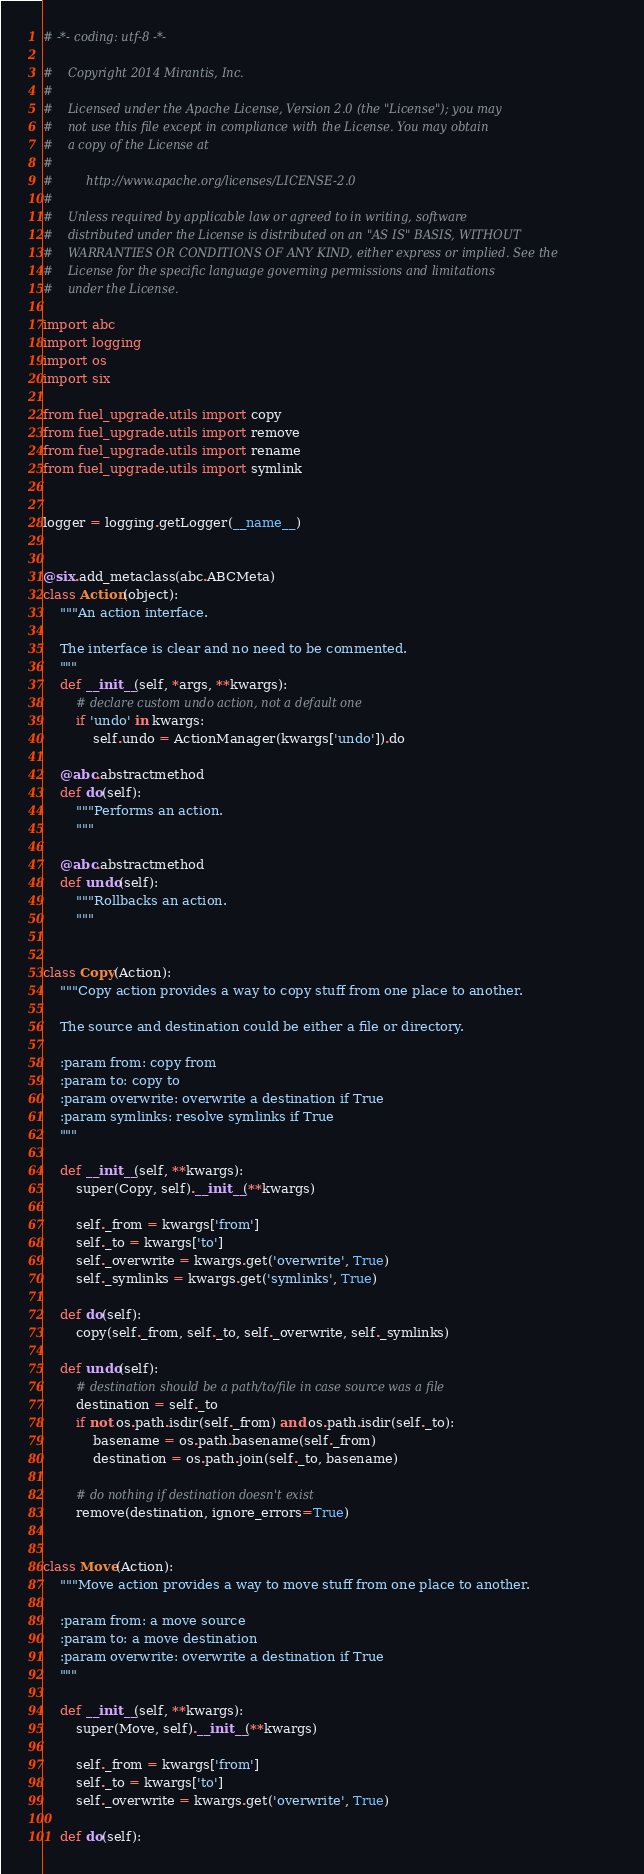<code> <loc_0><loc_0><loc_500><loc_500><_Python_># -*- coding: utf-8 -*-

#    Copyright 2014 Mirantis, Inc.
#
#    Licensed under the Apache License, Version 2.0 (the "License"); you may
#    not use this file except in compliance with the License. You may obtain
#    a copy of the License at
#
#         http://www.apache.org/licenses/LICENSE-2.0
#
#    Unless required by applicable law or agreed to in writing, software
#    distributed under the License is distributed on an "AS IS" BASIS, WITHOUT
#    WARRANTIES OR CONDITIONS OF ANY KIND, either express or implied. See the
#    License for the specific language governing permissions and limitations
#    under the License.

import abc
import logging
import os
import six

from fuel_upgrade.utils import copy
from fuel_upgrade.utils import remove
from fuel_upgrade.utils import rename
from fuel_upgrade.utils import symlink


logger = logging.getLogger(__name__)


@six.add_metaclass(abc.ABCMeta)
class Action(object):
    """An action interface.

    The interface is clear and no need to be commented.
    """
    def __init__(self, *args, **kwargs):
        # declare custom undo action, not a default one
        if 'undo' in kwargs:
            self.undo = ActionManager(kwargs['undo']).do

    @abc.abstractmethod
    def do(self):
        """Performs an action.
        """

    @abc.abstractmethod
    def undo(self):
        """Rollbacks an action.
        """


class Copy(Action):
    """Copy action provides a way to copy stuff from one place to another.

    The source and destination could be either a file or directory.

    :param from: copy from
    :param to: copy to
    :param overwrite: overwrite a destination if True
    :param symlinks: resolve symlinks if True
    """

    def __init__(self, **kwargs):
        super(Copy, self).__init__(**kwargs)

        self._from = kwargs['from']
        self._to = kwargs['to']
        self._overwrite = kwargs.get('overwrite', True)
        self._symlinks = kwargs.get('symlinks', True)

    def do(self):
        copy(self._from, self._to, self._overwrite, self._symlinks)

    def undo(self):
        # destination should be a path/to/file in case source was a file
        destination = self._to
        if not os.path.isdir(self._from) and os.path.isdir(self._to):
            basename = os.path.basename(self._from)
            destination = os.path.join(self._to, basename)

        # do nothing if destination doesn't exist
        remove(destination, ignore_errors=True)


class Move(Action):
    """Move action provides a way to move stuff from one place to another.

    :param from: a move source
    :param to: a move destination
    :param overwrite: overwrite a destination if True
    """

    def __init__(self, **kwargs):
        super(Move, self).__init__(**kwargs)

        self._from = kwargs['from']
        self._to = kwargs['to']
        self._overwrite = kwargs.get('overwrite', True)

    def do(self):</code> 